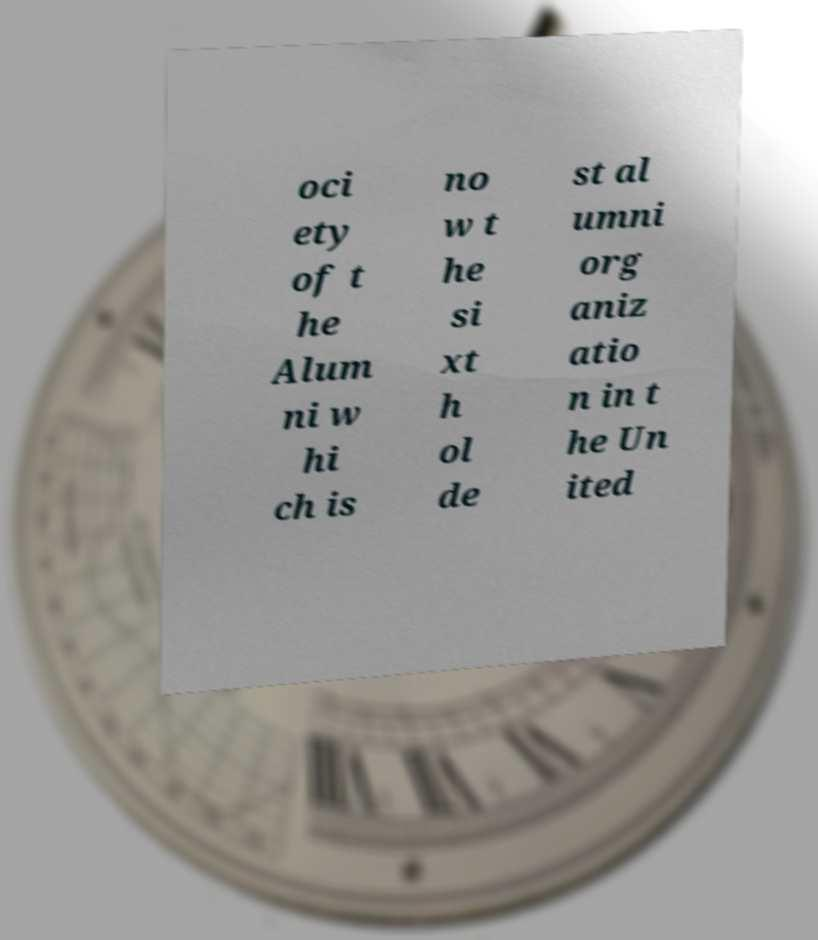Could you assist in decoding the text presented in this image and type it out clearly? oci ety of t he Alum ni w hi ch is no w t he si xt h ol de st al umni org aniz atio n in t he Un ited 